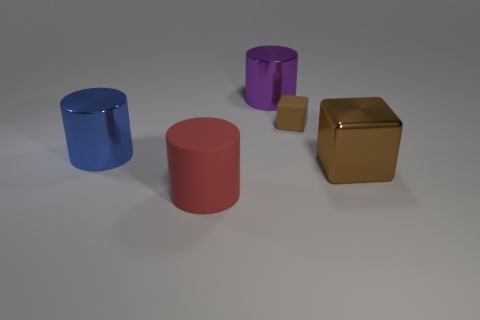How many brown blocks must be subtracted to get 1 brown blocks? 1 Subtract all cyan cylinders. Subtract all cyan blocks. How many cylinders are left? 3 Add 3 tiny brown things. How many objects exist? 8 Subtract all blocks. How many objects are left? 3 Subtract 1 purple cylinders. How many objects are left? 4 Subtract all tiny brown metal balls. Subtract all purple objects. How many objects are left? 4 Add 5 large red matte cylinders. How many large red matte cylinders are left? 6 Add 4 big yellow metallic spheres. How many big yellow metallic spheres exist? 4 